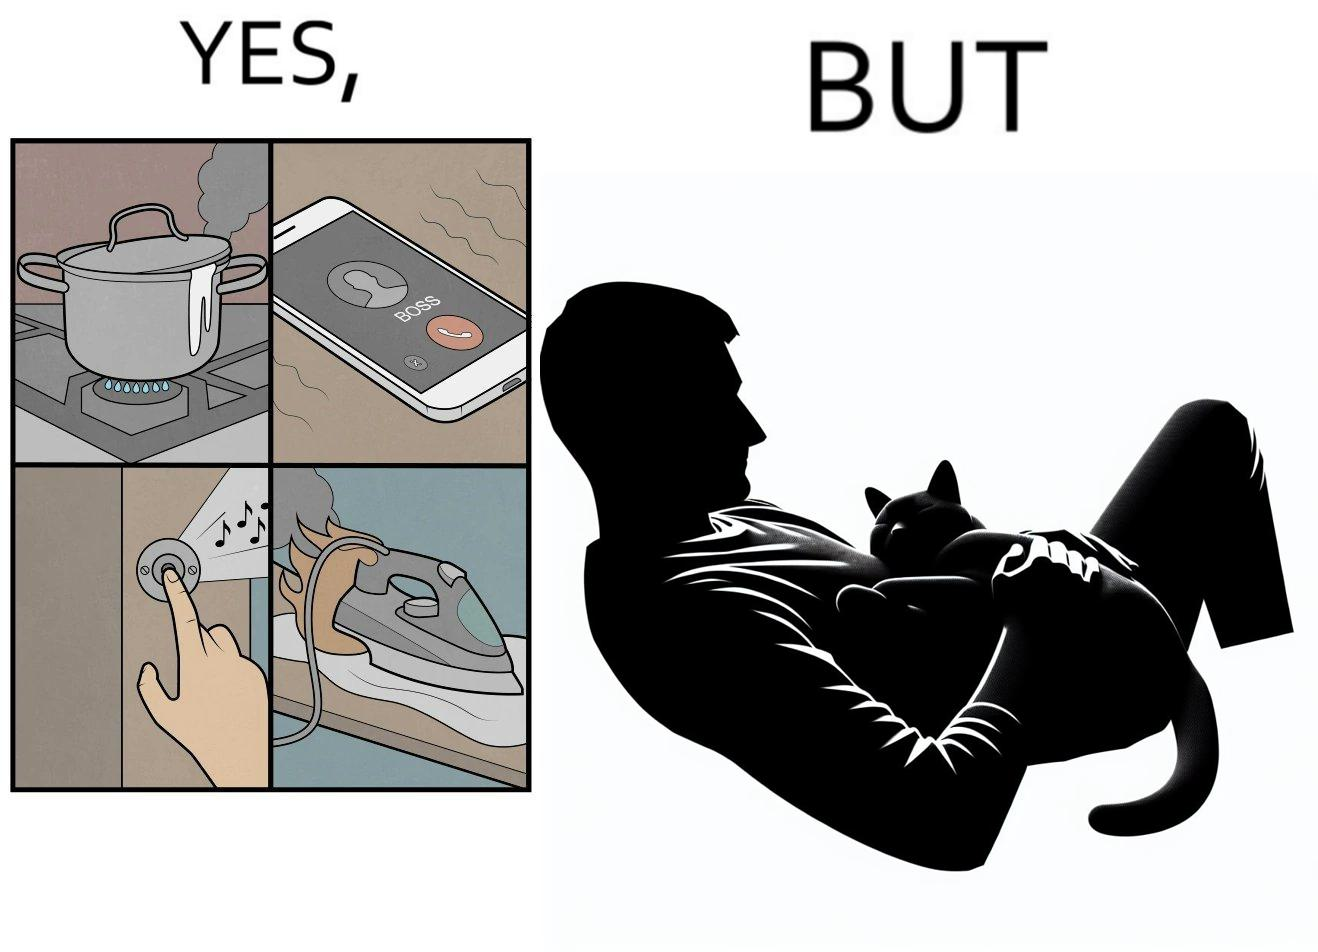Describe the contrast between the left and right parts of this image. In the left part of the image: Image depicts chaos in a household with overflowing pots, ringing phone, door bell going off, and the iron burning clothes In the right part of the image: a cat sleeping on the lap of a person 